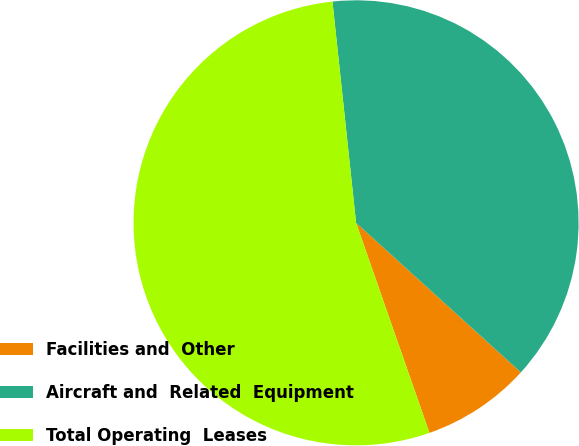Convert chart. <chart><loc_0><loc_0><loc_500><loc_500><pie_chart><fcel>Facilities and  Other<fcel>Aircraft and  Related  Equipment<fcel>Total Operating  Leases<nl><fcel>7.92%<fcel>38.42%<fcel>53.65%<nl></chart> 